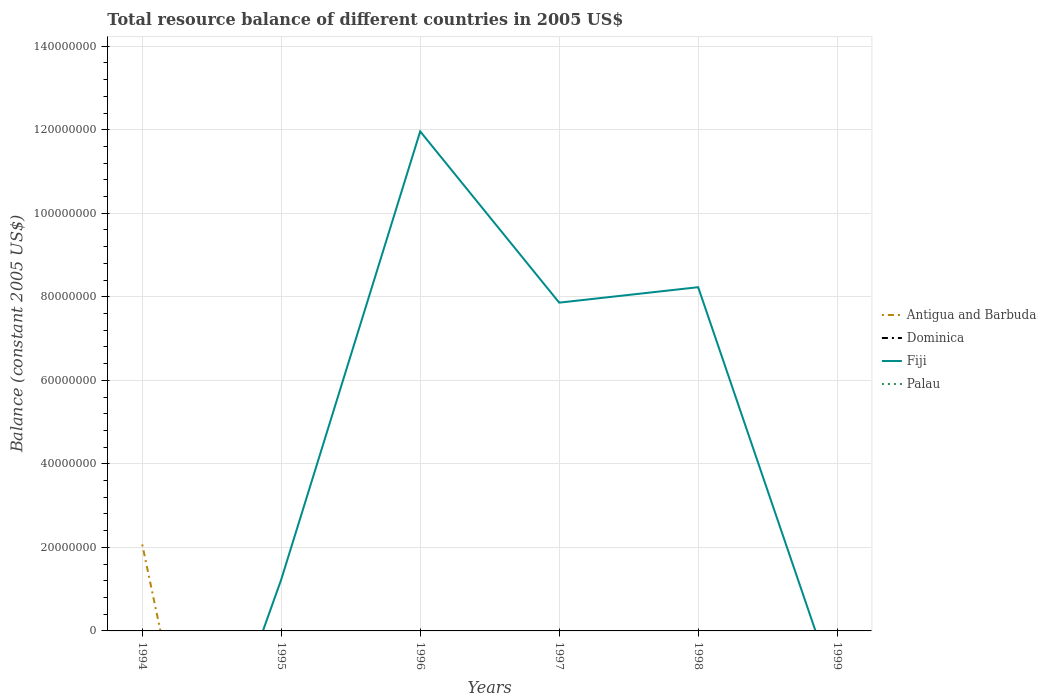What is the total total resource balance in Fiji in the graph?
Your answer should be very brief. -1.07e+08. What is the difference between the highest and the second highest total resource balance in Fiji?
Offer a very short reply. 1.20e+08. What is the difference between the highest and the lowest total resource balance in Palau?
Ensure brevity in your answer.  0. Is the total resource balance in Dominica strictly greater than the total resource balance in Palau over the years?
Keep it short and to the point. No. How many lines are there?
Provide a succinct answer. 2. Does the graph contain grids?
Your response must be concise. Yes. Where does the legend appear in the graph?
Your response must be concise. Center right. What is the title of the graph?
Offer a terse response. Total resource balance of different countries in 2005 US$. What is the label or title of the X-axis?
Your response must be concise. Years. What is the label or title of the Y-axis?
Your response must be concise. Balance (constant 2005 US$). What is the Balance (constant 2005 US$) in Antigua and Barbuda in 1994?
Your answer should be compact. 2.07e+07. What is the Balance (constant 2005 US$) of Fiji in 1994?
Keep it short and to the point. 0. What is the Balance (constant 2005 US$) in Dominica in 1995?
Provide a short and direct response. 0. What is the Balance (constant 2005 US$) in Fiji in 1995?
Your answer should be compact. 1.23e+07. What is the Balance (constant 2005 US$) of Fiji in 1996?
Offer a very short reply. 1.20e+08. What is the Balance (constant 2005 US$) in Palau in 1996?
Provide a short and direct response. 0. What is the Balance (constant 2005 US$) in Dominica in 1997?
Your answer should be very brief. 0. What is the Balance (constant 2005 US$) in Fiji in 1997?
Your answer should be very brief. 7.86e+07. What is the Balance (constant 2005 US$) in Antigua and Barbuda in 1998?
Give a very brief answer. 0. What is the Balance (constant 2005 US$) of Dominica in 1998?
Give a very brief answer. 0. What is the Balance (constant 2005 US$) of Fiji in 1998?
Your answer should be compact. 8.23e+07. What is the Balance (constant 2005 US$) of Dominica in 1999?
Your answer should be very brief. 0. Across all years, what is the maximum Balance (constant 2005 US$) of Antigua and Barbuda?
Your response must be concise. 2.07e+07. Across all years, what is the maximum Balance (constant 2005 US$) in Fiji?
Make the answer very short. 1.20e+08. Across all years, what is the minimum Balance (constant 2005 US$) of Antigua and Barbuda?
Offer a very short reply. 0. What is the total Balance (constant 2005 US$) of Antigua and Barbuda in the graph?
Offer a very short reply. 2.07e+07. What is the total Balance (constant 2005 US$) in Dominica in the graph?
Your answer should be very brief. 0. What is the total Balance (constant 2005 US$) in Fiji in the graph?
Ensure brevity in your answer.  2.93e+08. What is the total Balance (constant 2005 US$) of Palau in the graph?
Ensure brevity in your answer.  0. What is the difference between the Balance (constant 2005 US$) of Fiji in 1995 and that in 1996?
Offer a very short reply. -1.07e+08. What is the difference between the Balance (constant 2005 US$) in Fiji in 1995 and that in 1997?
Offer a very short reply. -6.63e+07. What is the difference between the Balance (constant 2005 US$) of Fiji in 1995 and that in 1998?
Offer a terse response. -7.00e+07. What is the difference between the Balance (constant 2005 US$) in Fiji in 1996 and that in 1997?
Keep it short and to the point. 4.10e+07. What is the difference between the Balance (constant 2005 US$) in Fiji in 1996 and that in 1998?
Offer a terse response. 3.73e+07. What is the difference between the Balance (constant 2005 US$) of Fiji in 1997 and that in 1998?
Give a very brief answer. -3.70e+06. What is the difference between the Balance (constant 2005 US$) of Antigua and Barbuda in 1994 and the Balance (constant 2005 US$) of Fiji in 1995?
Your response must be concise. 8.40e+06. What is the difference between the Balance (constant 2005 US$) of Antigua and Barbuda in 1994 and the Balance (constant 2005 US$) of Fiji in 1996?
Offer a terse response. -9.89e+07. What is the difference between the Balance (constant 2005 US$) of Antigua and Barbuda in 1994 and the Balance (constant 2005 US$) of Fiji in 1997?
Your response must be concise. -5.79e+07. What is the difference between the Balance (constant 2005 US$) of Antigua and Barbuda in 1994 and the Balance (constant 2005 US$) of Fiji in 1998?
Your answer should be compact. -6.16e+07. What is the average Balance (constant 2005 US$) of Antigua and Barbuda per year?
Offer a terse response. 3.45e+06. What is the average Balance (constant 2005 US$) in Fiji per year?
Ensure brevity in your answer.  4.88e+07. What is the average Balance (constant 2005 US$) of Palau per year?
Offer a very short reply. 0. What is the ratio of the Balance (constant 2005 US$) in Fiji in 1995 to that in 1996?
Keep it short and to the point. 0.1. What is the ratio of the Balance (constant 2005 US$) in Fiji in 1995 to that in 1997?
Your response must be concise. 0.16. What is the ratio of the Balance (constant 2005 US$) of Fiji in 1995 to that in 1998?
Keep it short and to the point. 0.15. What is the ratio of the Balance (constant 2005 US$) of Fiji in 1996 to that in 1997?
Provide a succinct answer. 1.52. What is the ratio of the Balance (constant 2005 US$) in Fiji in 1996 to that in 1998?
Offer a very short reply. 1.45. What is the ratio of the Balance (constant 2005 US$) of Fiji in 1997 to that in 1998?
Give a very brief answer. 0.95. What is the difference between the highest and the second highest Balance (constant 2005 US$) of Fiji?
Give a very brief answer. 3.73e+07. What is the difference between the highest and the lowest Balance (constant 2005 US$) of Antigua and Barbuda?
Offer a very short reply. 2.07e+07. What is the difference between the highest and the lowest Balance (constant 2005 US$) in Fiji?
Give a very brief answer. 1.20e+08. 